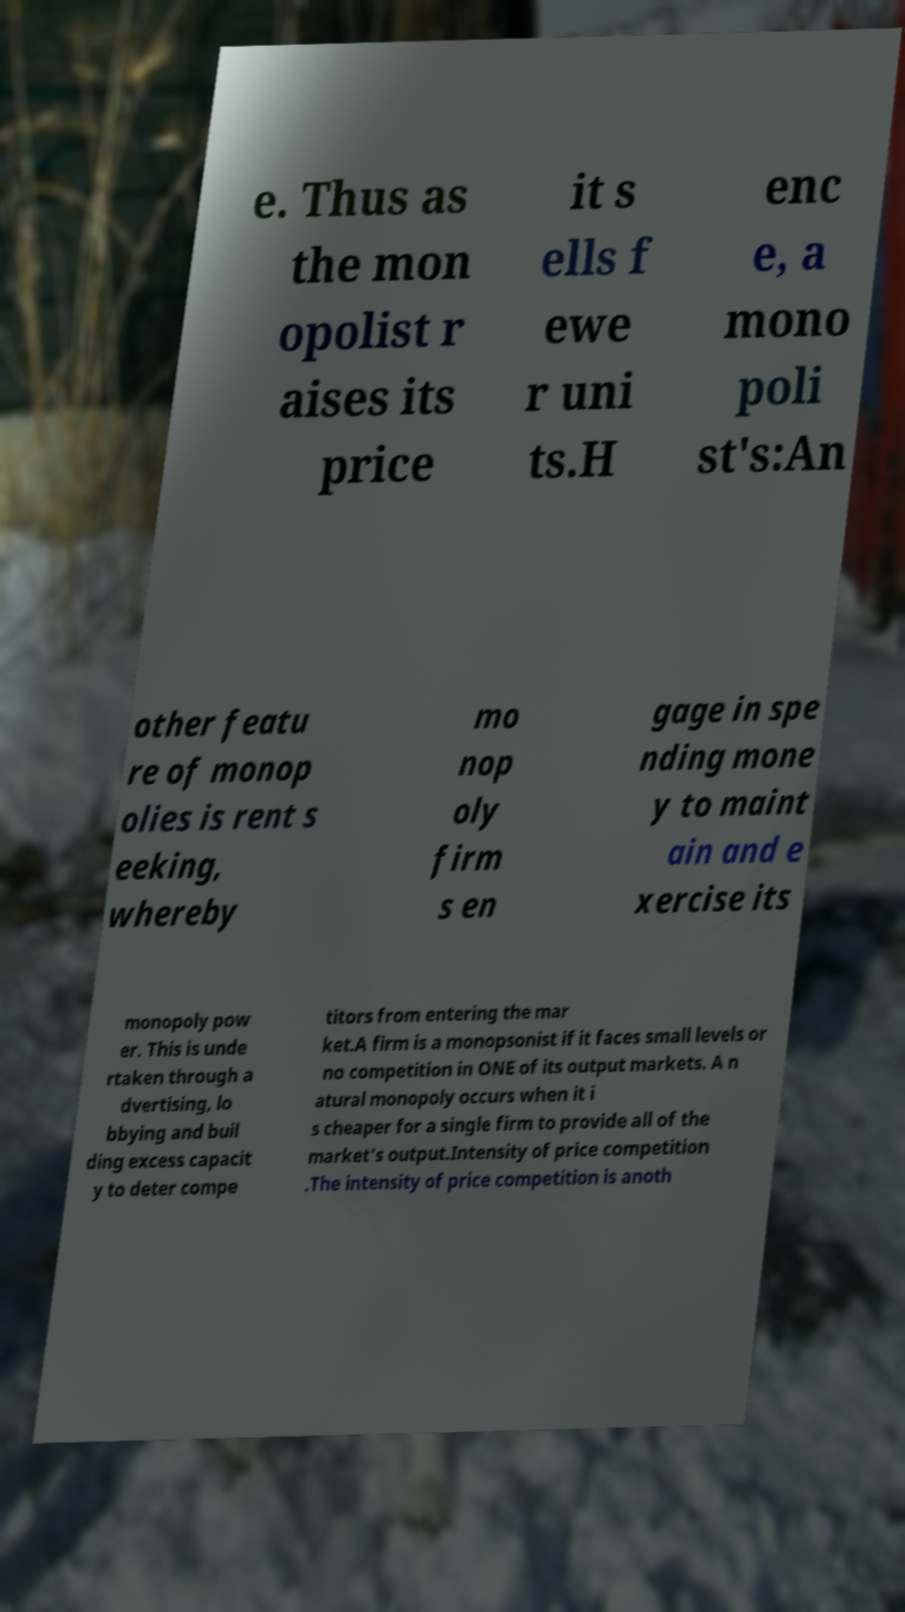Please identify and transcribe the text found in this image. e. Thus as the mon opolist r aises its price it s ells f ewe r uni ts.H enc e, a mono poli st's:An other featu re of monop olies is rent s eeking, whereby mo nop oly firm s en gage in spe nding mone y to maint ain and e xercise its monopoly pow er. This is unde rtaken through a dvertising, lo bbying and buil ding excess capacit y to deter compe titors from entering the mar ket.A firm is a monopsonist if it faces small levels or no competition in ONE of its output markets. A n atural monopoly occurs when it i s cheaper for a single firm to provide all of the market's output.Intensity of price competition .The intensity of price competition is anoth 